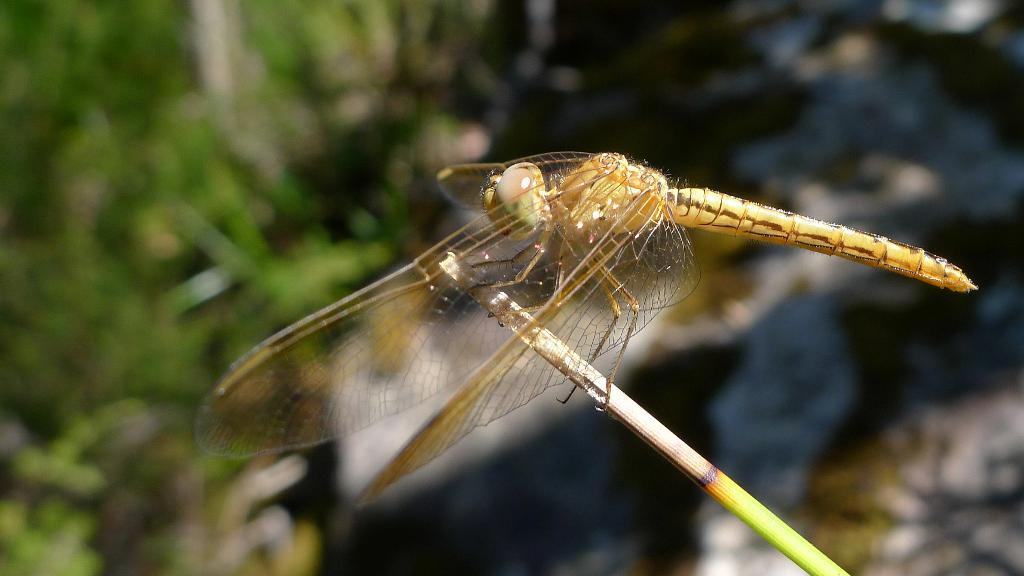What insect is present in the image? There is a dragonfly in the image. What is the dragonfly resting on? The dragonfly is on a thin stick. What can be seen in the background of the image? There are trees in the background of the image. What type of plate is the dragonfly sitting on in the image? There is no plate present in the image; the dragonfly is resting on a thin stick. 